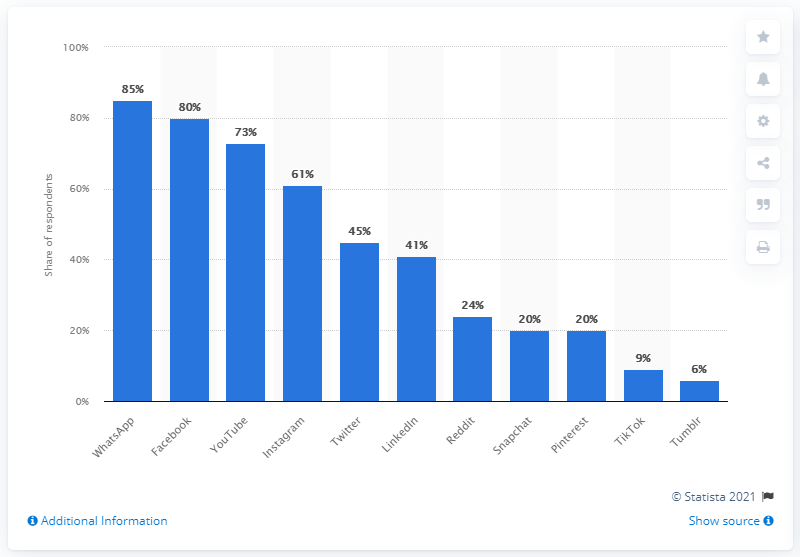Identify some key points in this picture. According to the data, WhatsApp was the most popular social media platform among individuals aged 26 to 35. Facebook was the second most popular social media platform. 